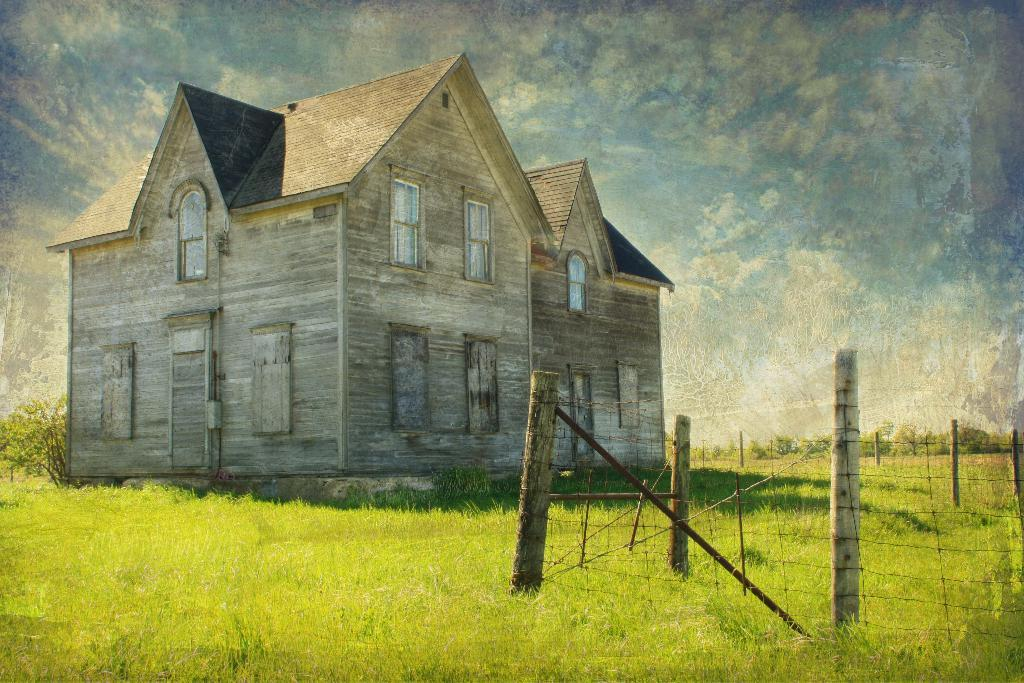What type of structure is visible in the image? There is a house in the image. What are the main features of the house? The house has walls and windows. What is present at the bottom of the image? There is grass at the bottom of the image. What type of barrier can be seen in the image? There is a fencing in the image. What other natural elements are visible in the image? There are trees in the image. What is visible in the background of the image? The sky is visible in the background of the image. How many credits are visible on the house in the image? There are no credits visible on the house in the image. What type of beam is supporting the trees in the image? There is no beam present in the image; the trees are standing on their own. 